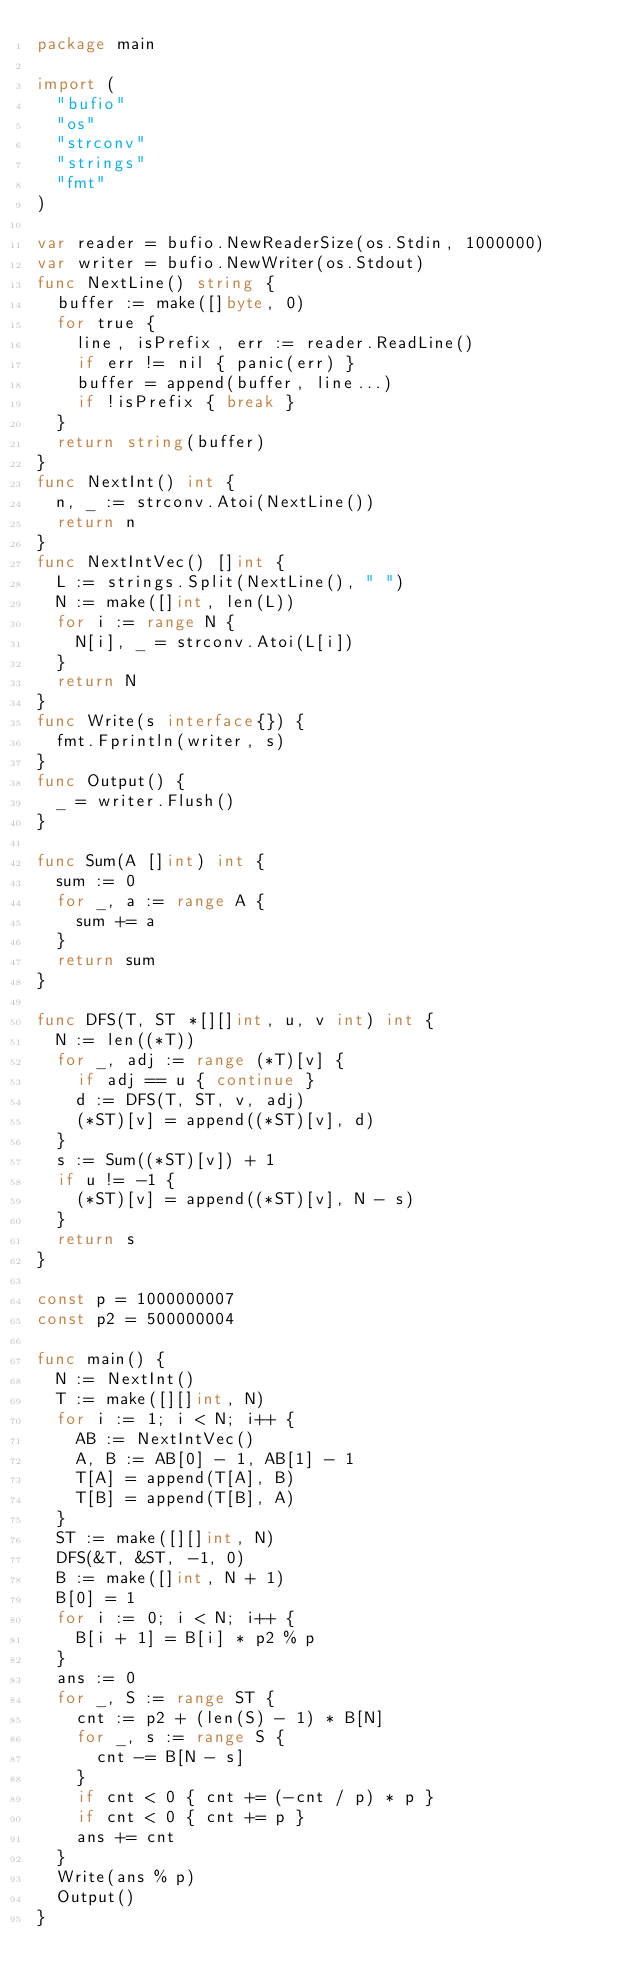Convert code to text. <code><loc_0><loc_0><loc_500><loc_500><_Go_>package main

import (
  "bufio"
  "os"
  "strconv"
  "strings"
  "fmt"
)

var reader = bufio.NewReaderSize(os.Stdin, 1000000)
var writer = bufio.NewWriter(os.Stdout)
func NextLine() string {
  buffer := make([]byte, 0)
  for true {
    line, isPrefix, err := reader.ReadLine()
    if err != nil { panic(err) }
    buffer = append(buffer, line...)
    if !isPrefix { break }
  }
  return string(buffer)
}
func NextInt() int {
  n, _ := strconv.Atoi(NextLine())
  return n
}
func NextIntVec() []int {
  L := strings.Split(NextLine(), " ")
  N := make([]int, len(L))
  for i := range N {
    N[i], _ = strconv.Atoi(L[i])
  }
  return N
}
func Write(s interface{}) {
  fmt.Fprintln(writer, s)
}
func Output() {
  _ = writer.Flush()
}

func Sum(A []int) int {
  sum := 0
  for _, a := range A {
    sum += a
  }
  return sum
}

func DFS(T, ST *[][]int, u, v int) int {
  N := len((*T))
  for _, adj := range (*T)[v] {
    if adj == u { continue }
    d := DFS(T, ST, v, adj)
    (*ST)[v] = append((*ST)[v], d)
  }
  s := Sum((*ST)[v]) + 1
  if u != -1 {
    (*ST)[v] = append((*ST)[v], N - s)
  }
  return s
}

const p = 1000000007
const p2 = 500000004

func main() {
  N := NextInt()
  T := make([][]int, N)
  for i := 1; i < N; i++ {
    AB := NextIntVec()
    A, B := AB[0] - 1, AB[1] - 1
    T[A] = append(T[A], B)
    T[B] = append(T[B], A)
  }
  ST := make([][]int, N)
  DFS(&T, &ST, -1, 0)
  B := make([]int, N + 1)
  B[0] = 1
  for i := 0; i < N; i++ {
    B[i + 1] = B[i] * p2 % p
  }
  ans := 0
  for _, S := range ST {
    cnt := p2 + (len(S) - 1) * B[N]
    for _, s := range S {
      cnt -= B[N - s]
    }
    if cnt < 0 { cnt += (-cnt / p) * p }
    if cnt < 0 { cnt += p }
    ans += cnt
  }
  Write(ans % p)
  Output()
}
</code> 